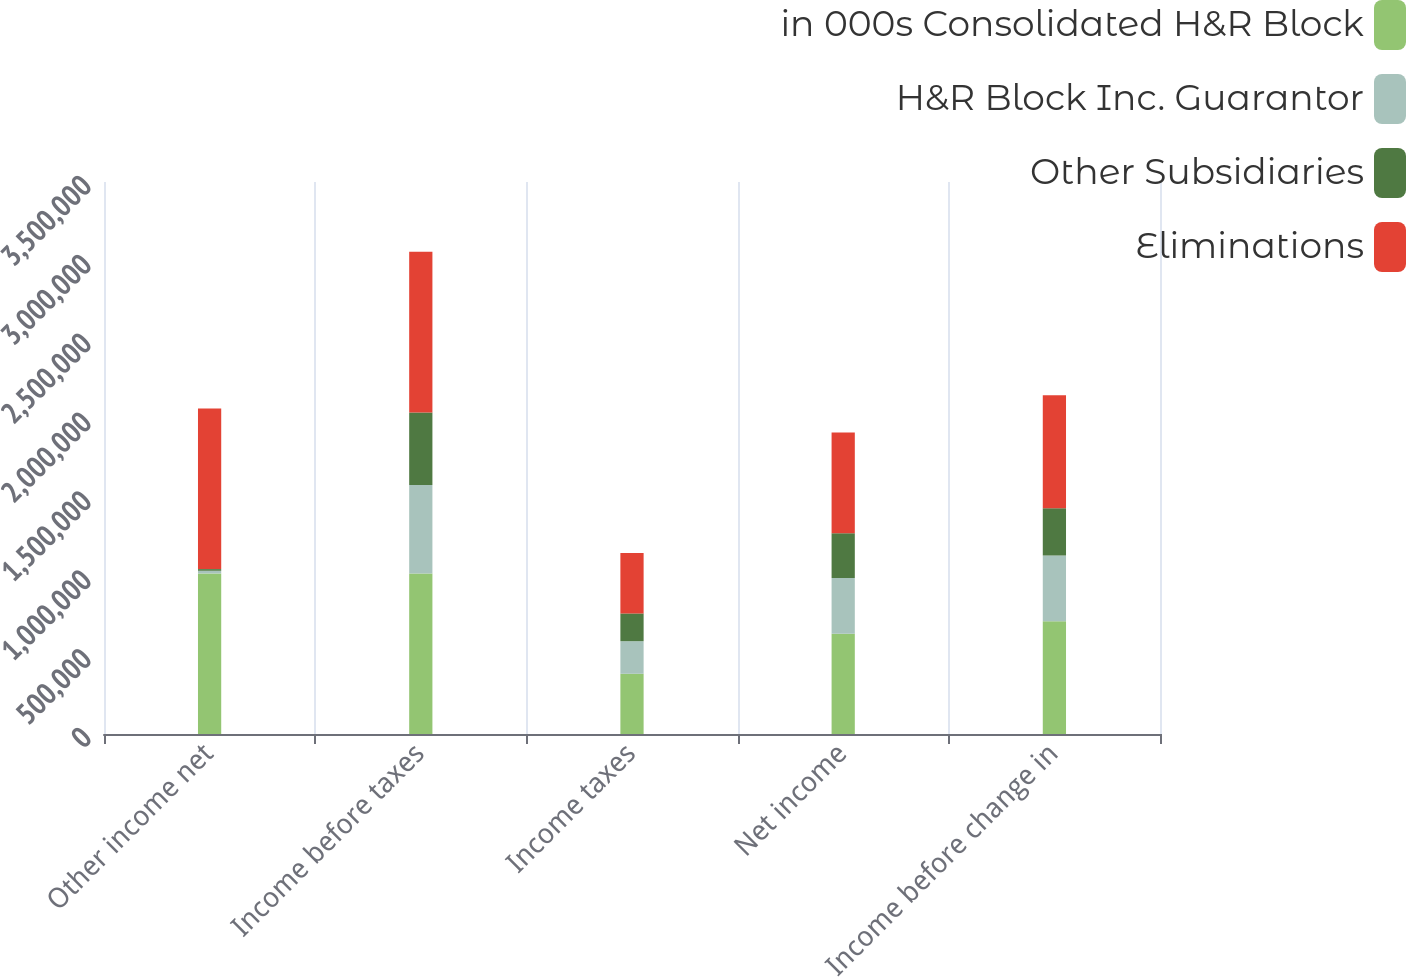Convert chart. <chart><loc_0><loc_0><loc_500><loc_500><stacked_bar_chart><ecel><fcel>Other income net<fcel>Income before taxes<fcel>Income taxes<fcel>Net income<fcel>Income before change in<nl><fcel>in 000s Consolidated H&R Block<fcel>1.01772e+06<fcel>1.01772e+06<fcel>381858<fcel>635857<fcel>715608<nl><fcel>H&R Block Inc. Guarantor<fcel>17277<fcel>560484<fcel>206572<fcel>353912<fcel>415728<nl><fcel>Other Subsidiaries<fcel>10552<fcel>459624<fcel>175969<fcel>283655<fcel>300109<nl><fcel>Eliminations<fcel>1.01772e+06<fcel>1.02011e+06<fcel>382541<fcel>637567<fcel>715837<nl></chart> 